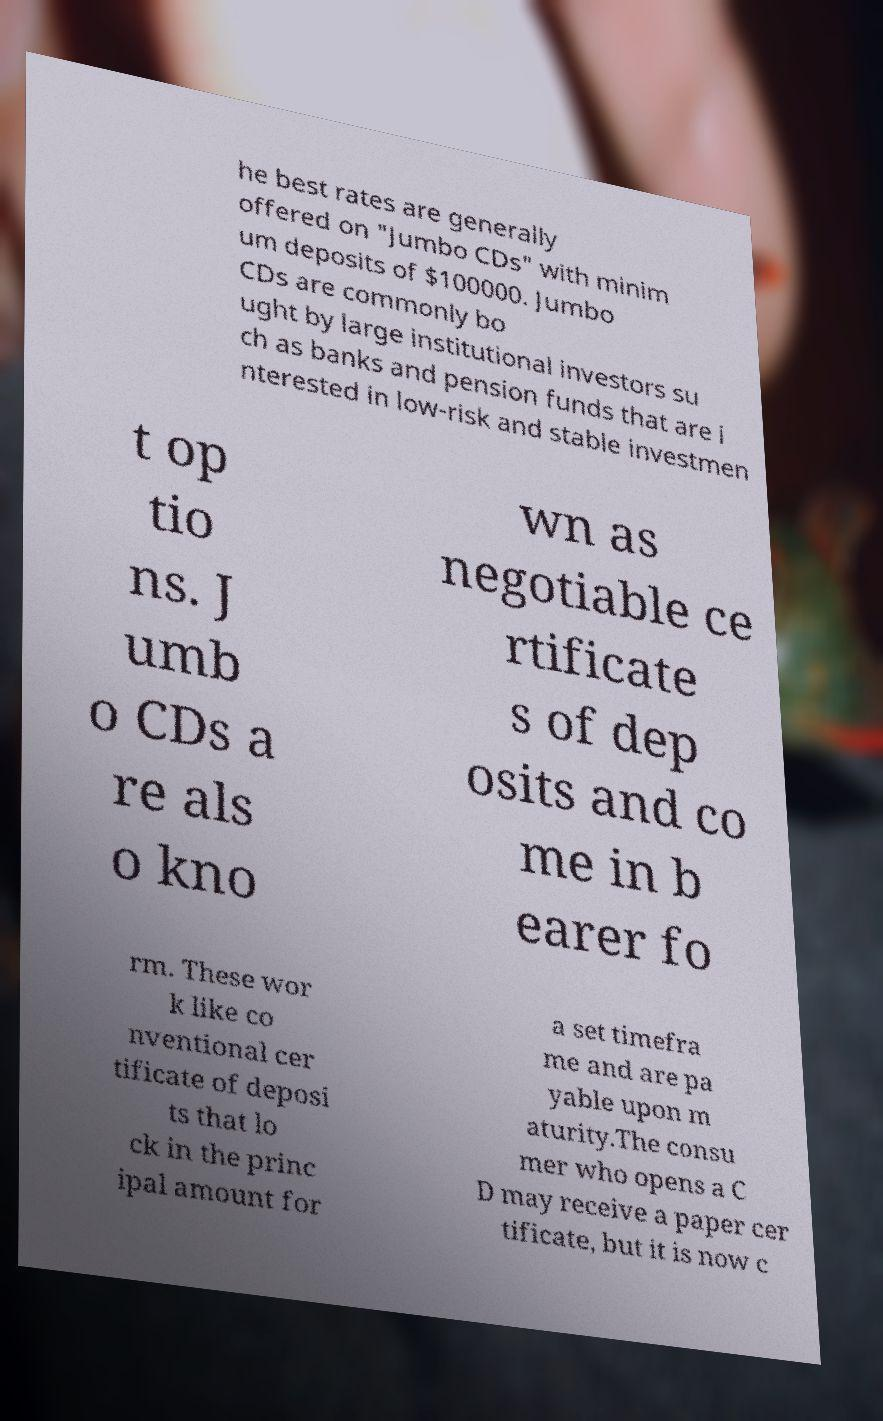There's text embedded in this image that I need extracted. Can you transcribe it verbatim? he best rates are generally offered on "Jumbo CDs" with minim um deposits of $100000. Jumbo CDs are commonly bo ught by large institutional investors su ch as banks and pension funds that are i nterested in low-risk and stable investmen t op tio ns. J umb o CDs a re als o kno wn as negotiable ce rtificate s of dep osits and co me in b earer fo rm. These wor k like co nventional cer tificate of deposi ts that lo ck in the princ ipal amount for a set timefra me and are pa yable upon m aturity.The consu mer who opens a C D may receive a paper cer tificate, but it is now c 